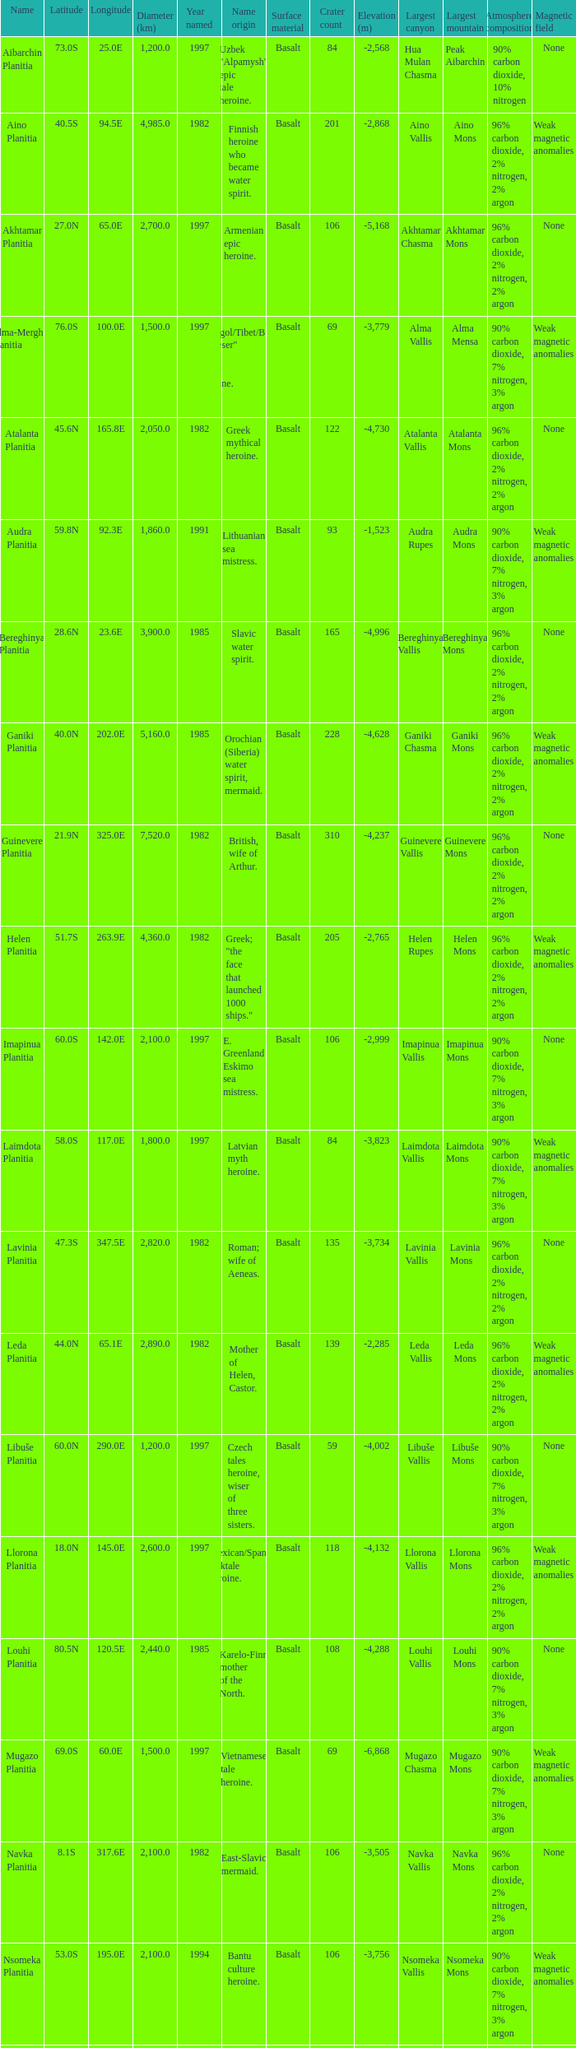What is the diameter (km) of feature of latitude 40.5s 4985.0. 